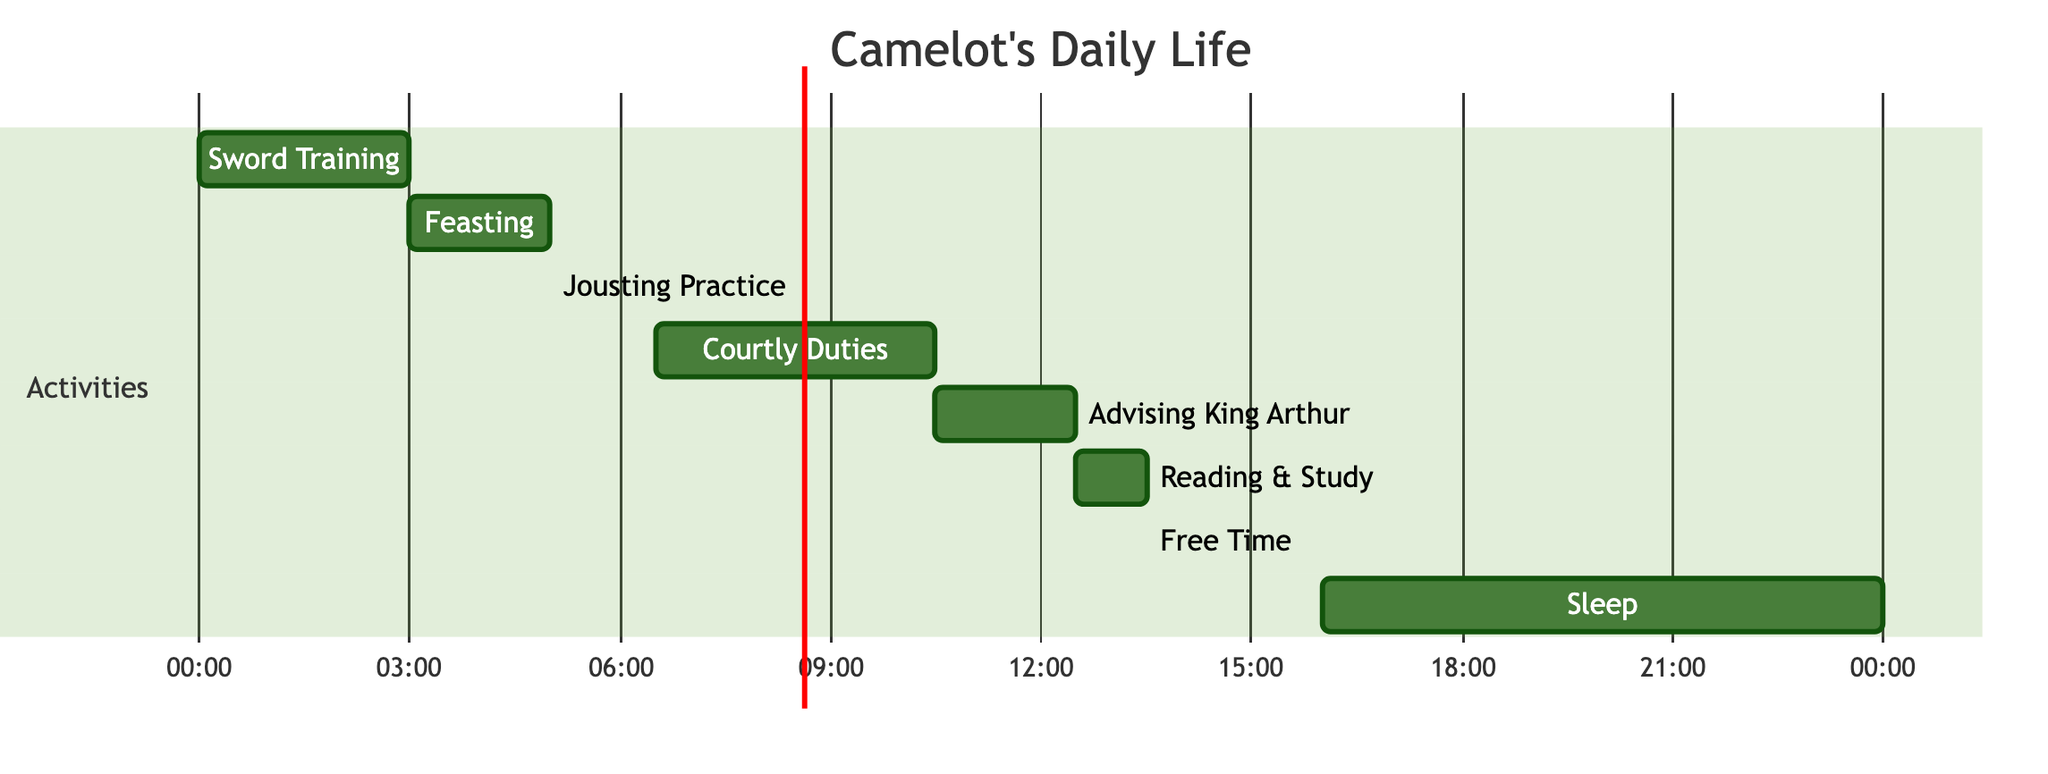What is the longest activity in Camelot's daily life? The longest activity is Sleep, which lasts for 8 hours. This is determined by looking at the durations of all activities in the diagram, and Sleep has the highest time allocation.
Answer: Sleep How many activities are shown in the diagram? There are 7 activities represented in the diagram. Each distinct activity from Sword Training to Sleep counts as one node, leading to a total of 7.
Answer: 7 What time does Courtly Duties start? Courtly Duties starts at 06:30, as indicated by the time allocation shown beside the activity in the diagram.
Answer: 06:30 How long is the Free Time activity? Free Time lasts for 2 hours and 30 minutes, which is specifically noted in the activity's duration on the diagram.
Answer: 2h30m Which activity comes immediately after Jousting Practice? After Jousting Practice, which ends at 07:30, the next activity is Courtly Duties that starts immediately at 07:30. This is found by checking the end time of Jousting Practice and the start time of the next activity.
Answer: Courtly Duties What total time is allocated to training-related activities (Sword Training and Jousting Practice)? The total time for training-related activities is 4 hours and 30 minutes. This is calculated by adding Sword Training (3 hours) and Jousting Practice (1 hour and 30 minutes).
Answer: 4h30m What is the first activity of the day? The first activity of the day is Sword Training, which starts at 00:00. This is clearly shown as the first activity in the order provided in the diagram.
Answer: Sword Training Which activity has the same duration as Advising King Arthur? The activity Reading & Study has the same duration of 1 hour. Both activities are allocated the same time, which can be verified by examining their respective durations.
Answer: Reading & Study 